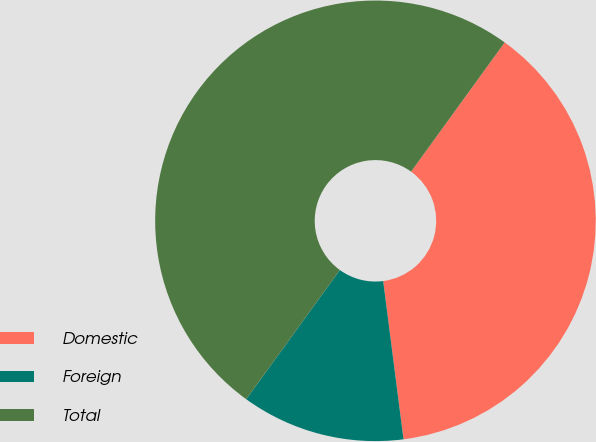Convert chart to OTSL. <chart><loc_0><loc_0><loc_500><loc_500><pie_chart><fcel>Domestic<fcel>Foreign<fcel>Total<nl><fcel>37.99%<fcel>12.01%<fcel>50.0%<nl></chart> 